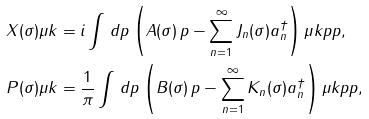Convert formula to latex. <formula><loc_0><loc_0><loc_500><loc_500>X ( \sigma ) \mu k & = i \int \, d p \left ( A ( \sigma ) \, p - \sum _ { n = 1 } ^ { \infty } J _ { n } ( \sigma ) a _ { n } ^ { \dagger } \right ) \mu k p { p } , \\ P ( \sigma ) \mu k & = \frac { 1 } { \pi } \int \, d p \left ( B ( \sigma ) \, p - \sum _ { n = 1 } ^ { \infty } K _ { n } ( \sigma ) a _ { n } ^ { \dagger } \right ) \mu k p { p } ,</formula> 